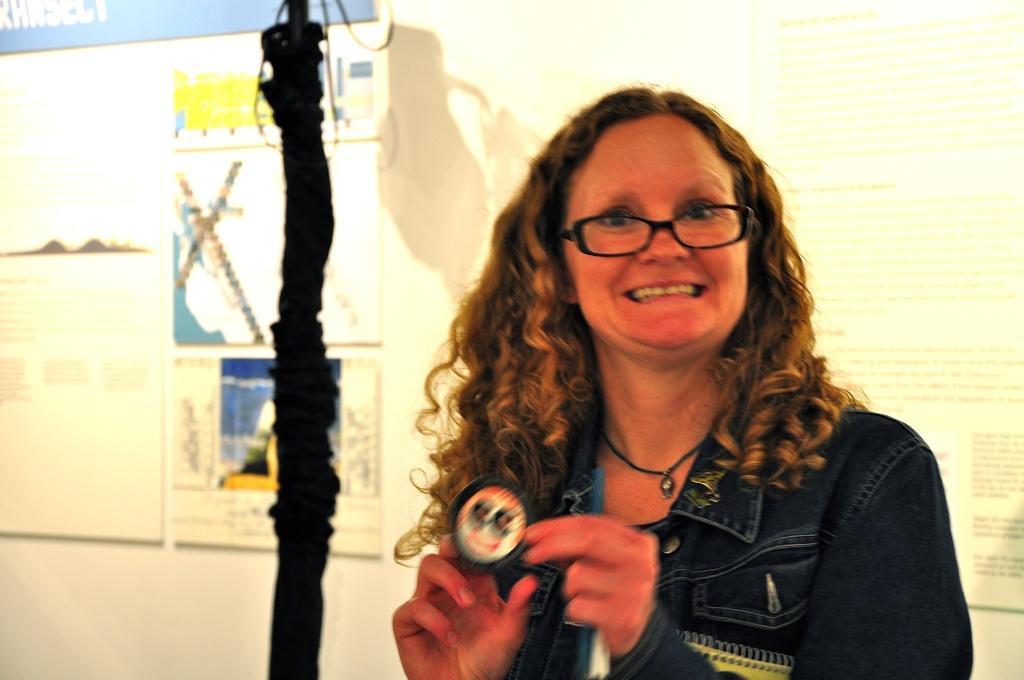Describe this image in one or two sentences. In this image we can see a person standing and holding an object, there is a rod beside the person and there are few posters to the wall in the background. 